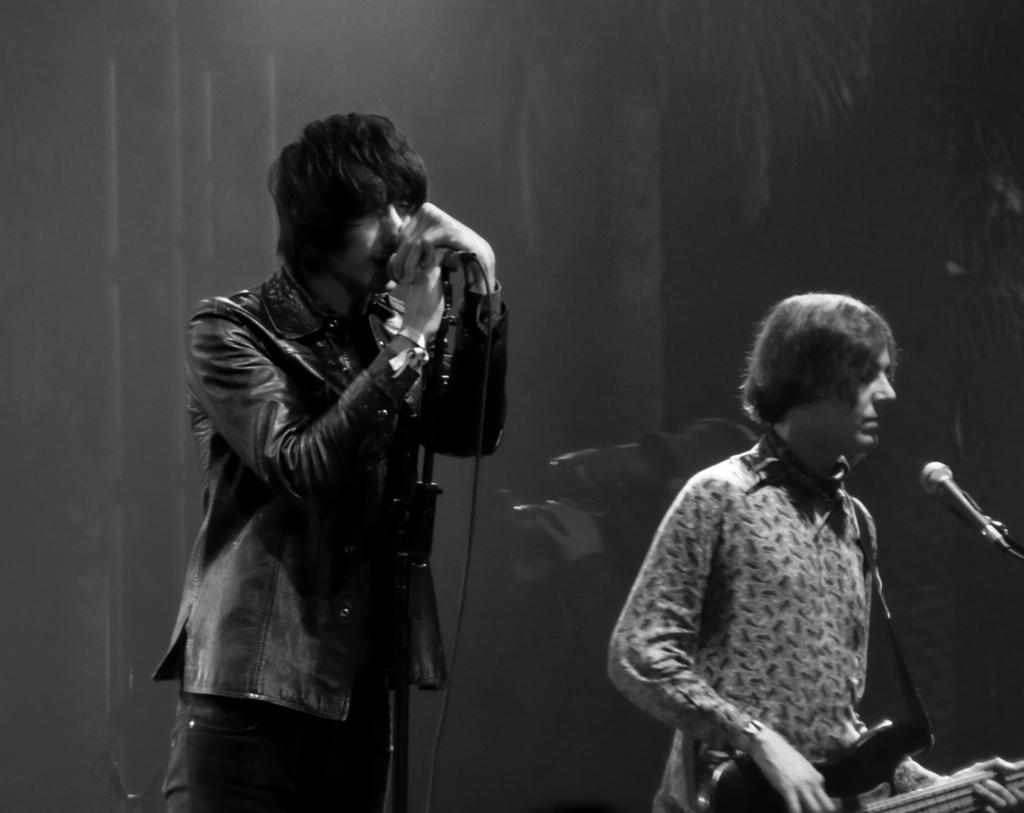Please provide a concise description of this image. Here we see a man standing and singing with the help of a microphone and a other man playing guitar. 